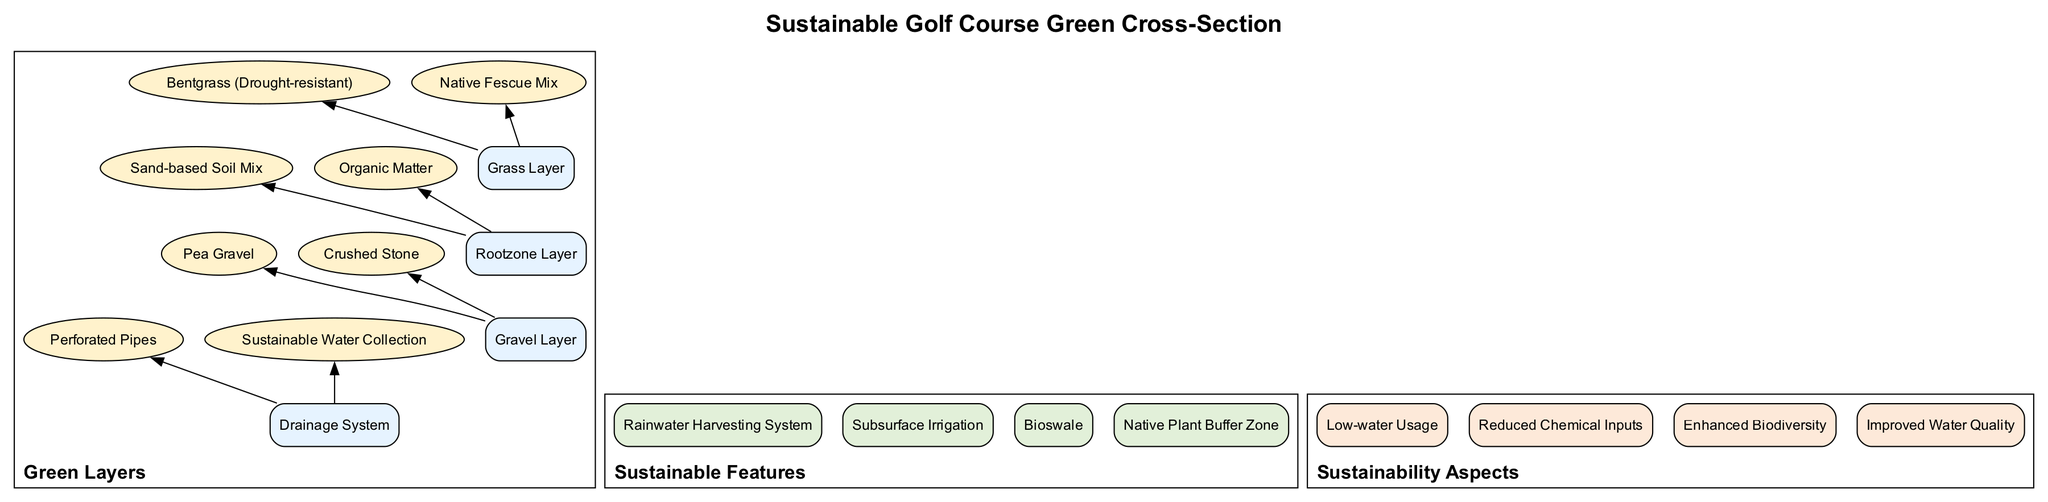What is the top layer of the green? The diagram shows that the top layer is labeled as the "Grass Layer." This is the first layer visible when observing the cross-section from the top down.
Answer: Grass Layer How many components are in the Rootzone Layer? The Rootzone Layer contains two components: "Sand-based Soil Mix" and "Organic Matter." By counting them from the diagram, we find there are exactly two.
Answer: 2 What type of grass is drought-resistant? The diagram specifies that "Bentgrass" is the drought-resistant option within the Grass Layer. This is a key component contributing to sustainability.
Answer: Bentgrass What is the function of the drainage system? The diagram identifies the "Drainage System" and lists its components: "Perforated Pipes" and "Sustainable Water Collection." These elements work together to manage water effectively beneath the green.
Answer: Manage water Which layer supports drainage? The "Gravel Layer" is directly responsible for facilitating drainage within the green, as it contains components suitable for this purpose, such as "Pea Gravel" and "Crushed Stone."
Answer: Gravel Layer How many sustainable features are listed? The diagram shows a total of four sustainable features enumerated clearly within their subgraph. Each feature contributes to the overall environmental strategy of the golf course.
Answer: 4 What does the bioswale do? "Bioswale" is one of the features listed in the diagram and generally serves to manage stormwater runoff by filtering pollutants, helping improve water quality and manage excess water.
Answer: Manage stormwater Which grass type is part of the Native Fescue Mix? The "Native Fescue Mix" is noted as a component in the Grass Layer, specifically highlighting its role in promoting local flora and adapting well to the environment.
Answer: Native Fescue Mix What aspect enhances biodiversity? The sustainability aspect "Enhanced Biodiversity" indicates the ecological diversity fostered by the choices made in the golf course's design and management, as shown in the diagram.
Answer: Enhanced Biodiversity 